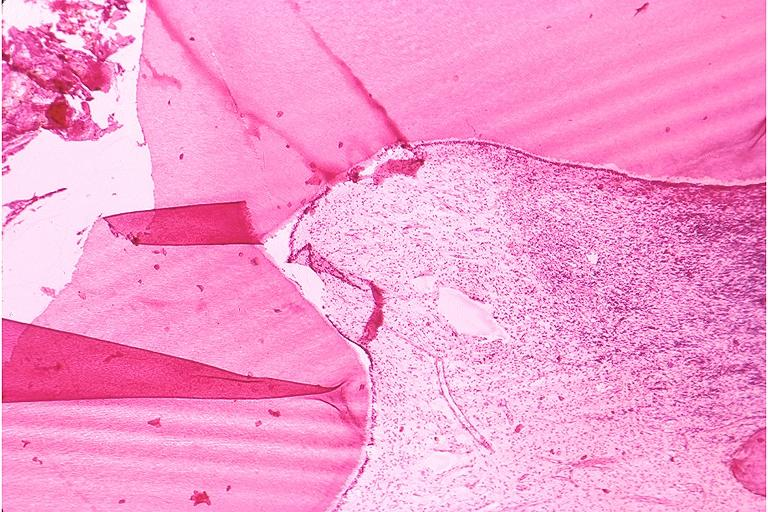where is this?
Answer the question using a single word or phrase. Oral 